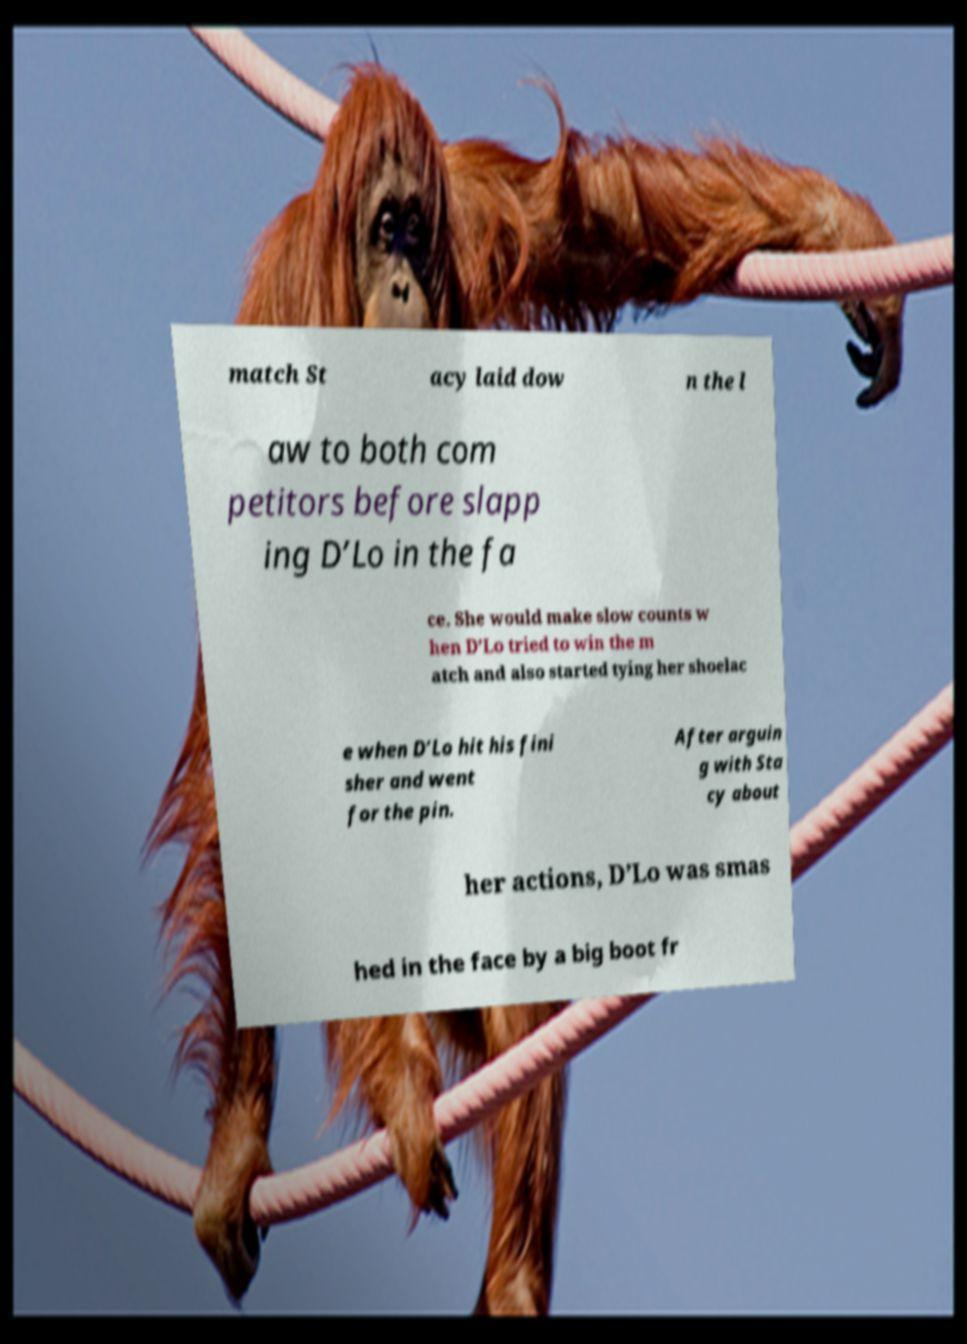What messages or text are displayed in this image? I need them in a readable, typed format. match St acy laid dow n the l aw to both com petitors before slapp ing D’Lo in the fa ce. She would make slow counts w hen D’Lo tried to win the m atch and also started tying her shoelac e when D’Lo hit his fini sher and went for the pin. After arguin g with Sta cy about her actions, D’Lo was smas hed in the face by a big boot fr 